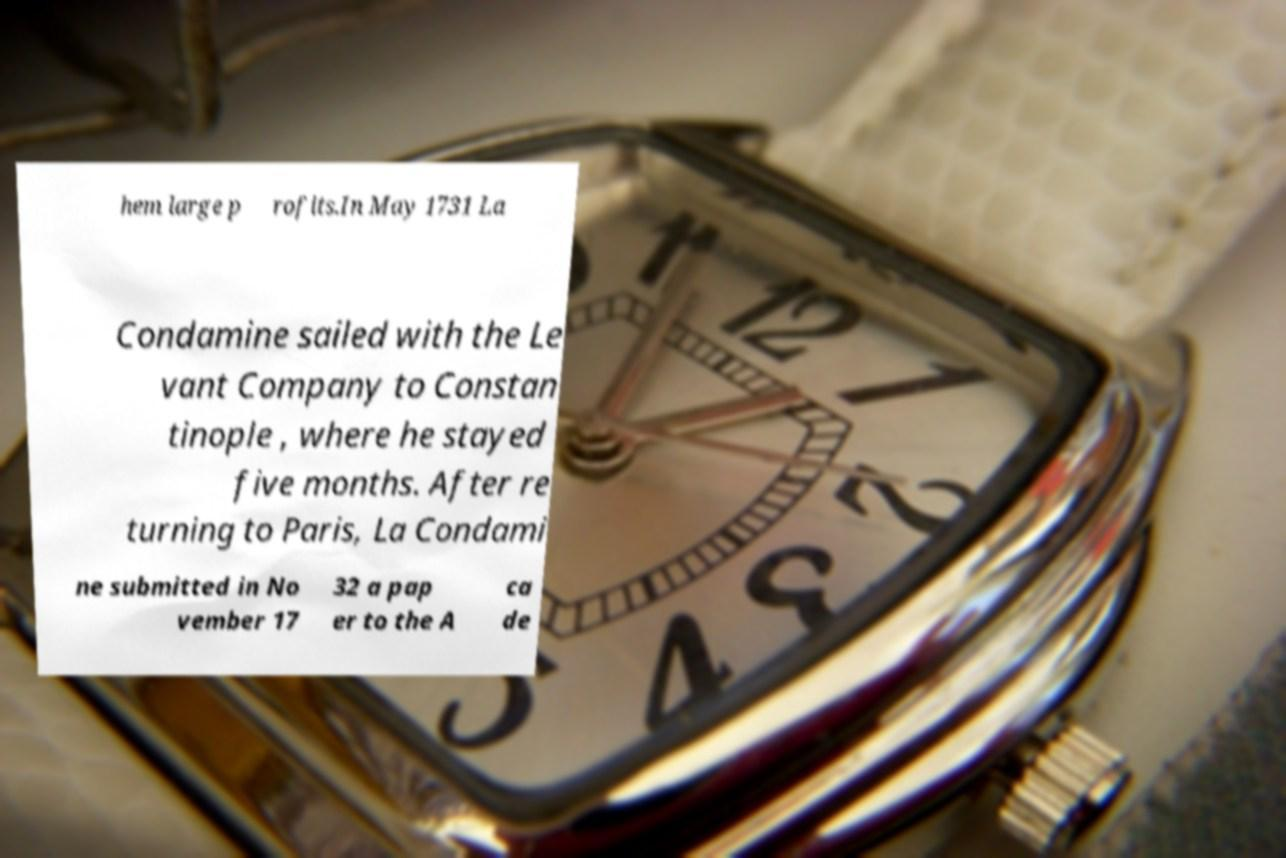I need the written content from this picture converted into text. Can you do that? hem large p rofits.In May 1731 La Condamine sailed with the Le vant Company to Constan tinople , where he stayed five months. After re turning to Paris, La Condami ne submitted in No vember 17 32 a pap er to the A ca de 